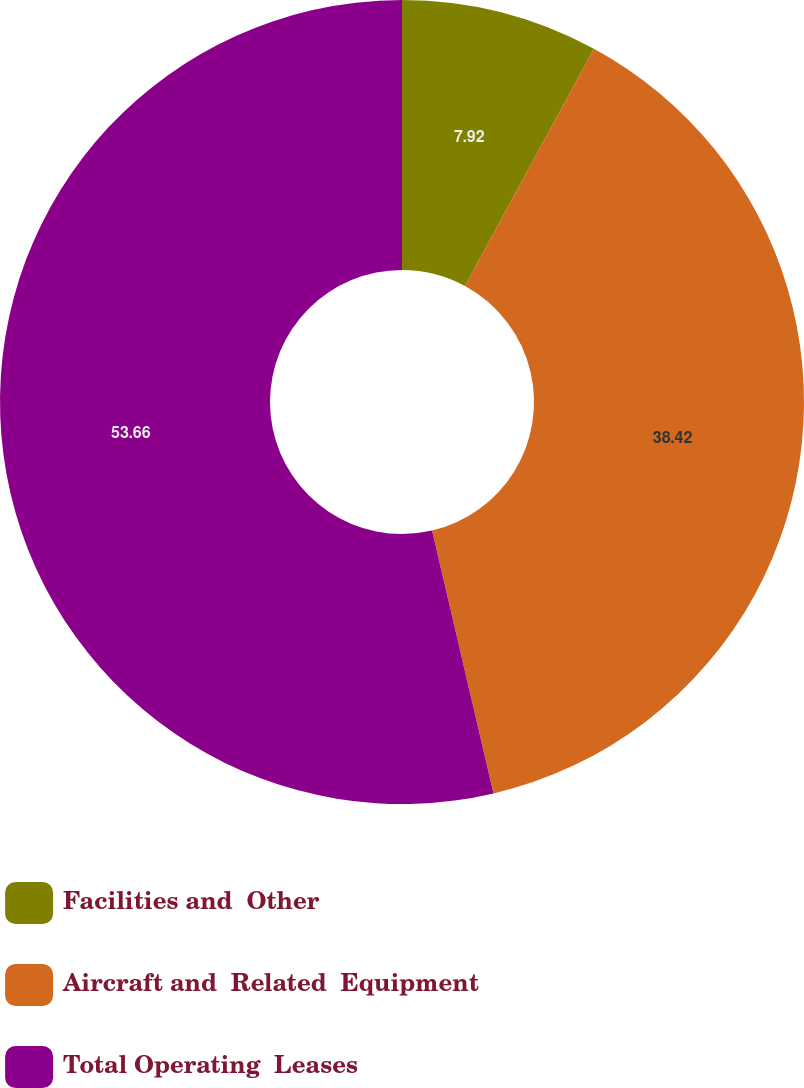<chart> <loc_0><loc_0><loc_500><loc_500><pie_chart><fcel>Facilities and  Other<fcel>Aircraft and  Related  Equipment<fcel>Total Operating  Leases<nl><fcel>7.92%<fcel>38.42%<fcel>53.65%<nl></chart> 